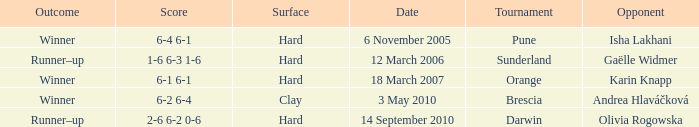What was the score of the tournament against Isha Lakhani? 6-4 6-1. 